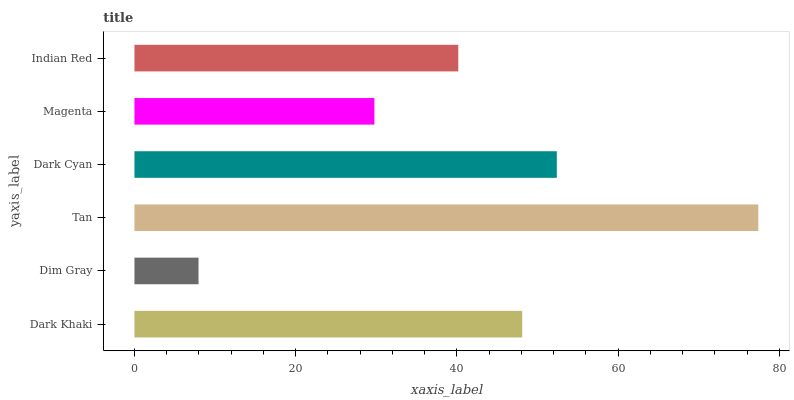Is Dim Gray the minimum?
Answer yes or no. Yes. Is Tan the maximum?
Answer yes or no. Yes. Is Tan the minimum?
Answer yes or no. No. Is Dim Gray the maximum?
Answer yes or no. No. Is Tan greater than Dim Gray?
Answer yes or no. Yes. Is Dim Gray less than Tan?
Answer yes or no. Yes. Is Dim Gray greater than Tan?
Answer yes or no. No. Is Tan less than Dim Gray?
Answer yes or no. No. Is Dark Khaki the high median?
Answer yes or no. Yes. Is Indian Red the low median?
Answer yes or no. Yes. Is Dark Cyan the high median?
Answer yes or no. No. Is Dark Khaki the low median?
Answer yes or no. No. 